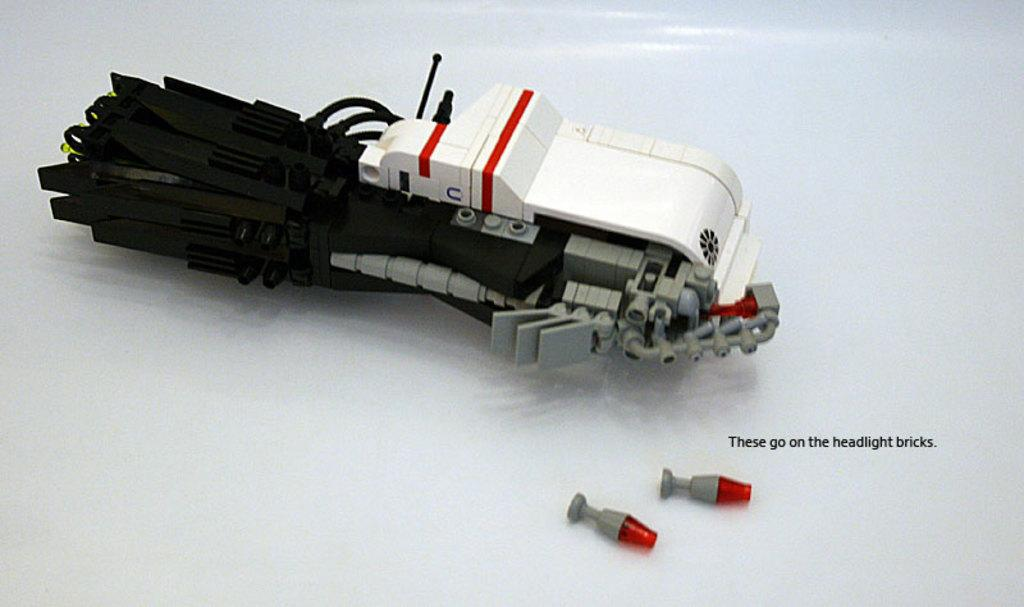What can be seen in the image? There are objects in the image. Can you describe one of the objects in the image? There is an object that looks like a light in the image. Is there any text present in the image? Yes, there is text in the image. What is the color of the background in the image? The background of the image is white in color. Can you tell me how many lips are visible in the image? There are no lips present in the image. What type of rail can be seen in the image? There is no rail present in the image. 